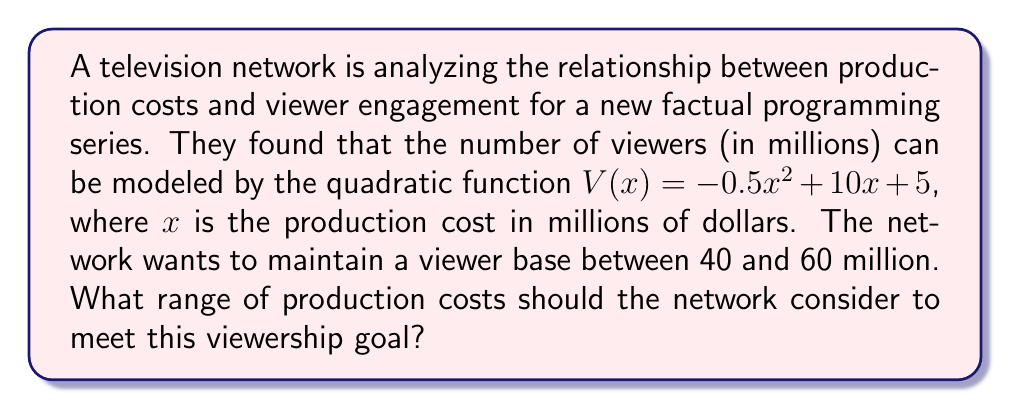Solve this math problem. 1) We need to solve the quadratic inequality:
   $40 \leq -0.5x^2 + 10x + 5 \leq 60$

2) Let's solve each part separately:
   
   a) $-0.5x^2 + 10x + 5 \geq 40$
      $-0.5x^2 + 10x - 35 \geq 0$
      
   b) $-0.5x^2 + 10x + 5 \leq 60$
      $-0.5x^2 + 10x - 55 \leq 0$

3) For inequality a):
   $-0.5(x^2 - 20x + 70) \geq 0$
   $-0.5(x - 10)^2 + 30 \geq 0$
   $(x - 10)^2 \leq 60$
   $-\sqrt{60} \leq x - 10 \leq \sqrt{60}$
   $10 - \sqrt{60} \leq x \leq 10 + \sqrt{60}$

4) For inequality b):
   $-0.5(x^2 - 20x + 110) \leq 0$
   $-0.5(x - 10)^2 + 5 \leq 0$
   $(x - 10)^2 \geq 10$
   $x - 10 \leq -\sqrt{10}$ or $x - 10 \geq \sqrt{10}$
   $x \leq 10 - \sqrt{10}$ or $x \geq 10 + \sqrt{10}$

5) Combining the results from steps 3 and 4:
   $10 + \sqrt{10} \leq x \leq 10 + \sqrt{60}$

6) Rounding to two decimal places:
   $13.16 \leq x \leq 17.75$
Answer: $[13.16, 17.75]$ million dollars 